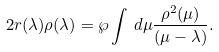<formula> <loc_0><loc_0><loc_500><loc_500>2 r ( \lambda ) \rho ( \lambda ) = \wp \int \, d \mu \frac { \rho ^ { 2 } ( \mu ) } { ( \mu - \lambda ) } .</formula> 